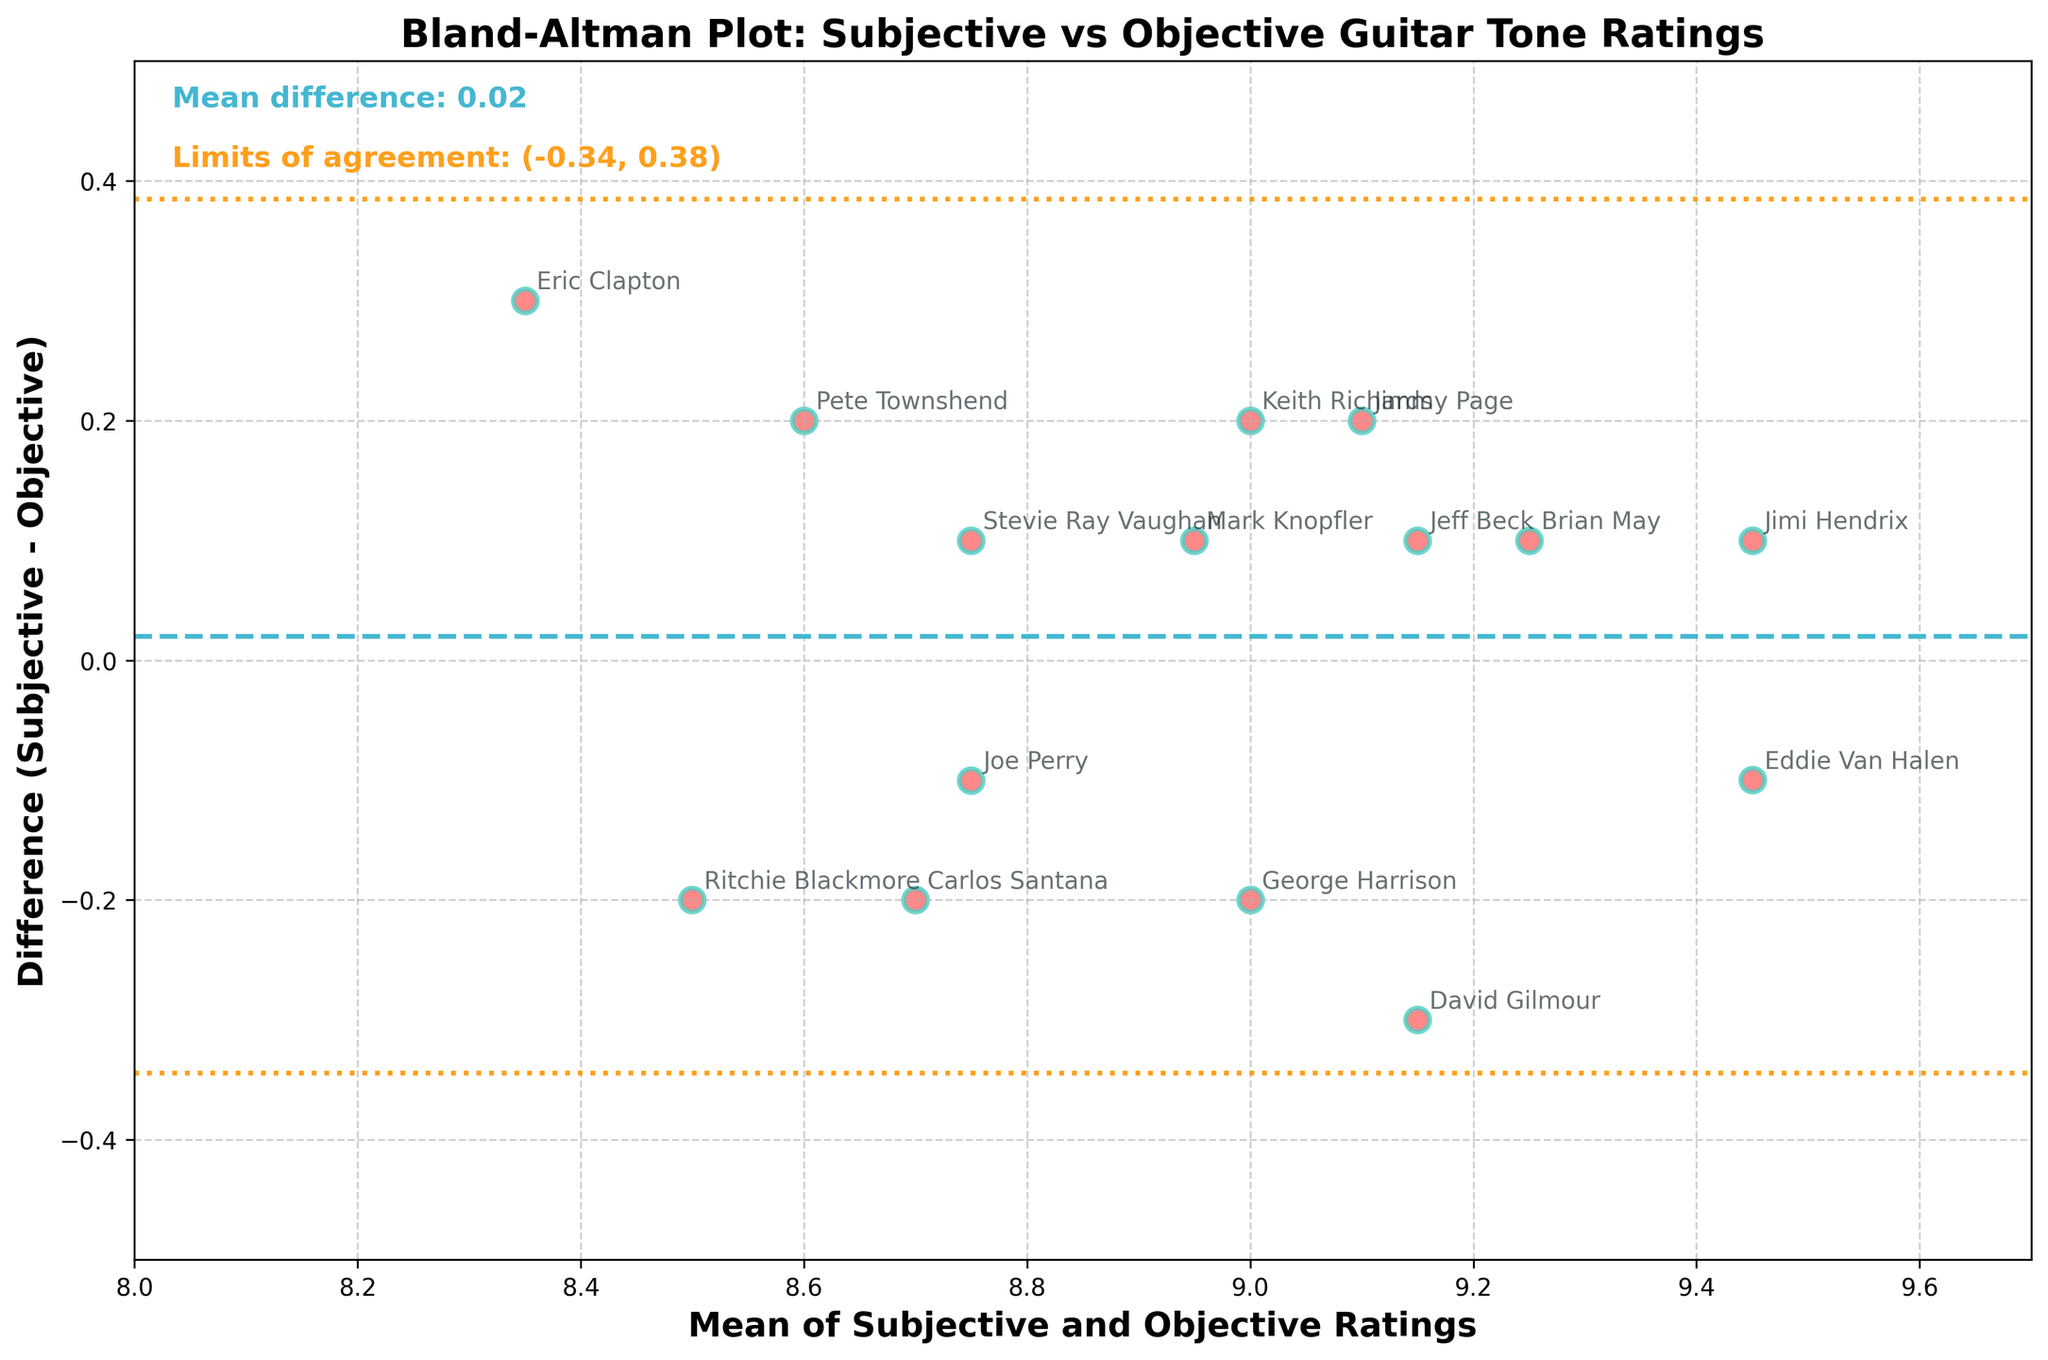What is the title of the figure? The title is usually displayed at the top of the figure and provides a summary of what the figure represents. By looking at the top of the figure, we can see the title "Bland-Altman Plot: Subjective vs Objective Guitar Tone Ratings".
Answer: Bland-Altman Plot: Subjective vs Objective Guitar Tone Ratings How many guitarists' tone ratings are plotted in the figure? By counting the number of individual data points or annotated names in the scatter plot, we can determine the total number of guitarists. Each guitarist has one corresponding data point.
Answer: 15 What do the horizontal dashed and dotted lines represent in this plot? The dashed line represents the mean difference between subjective and objective ratings, while the dotted lines represent the limits of agreement (mean difference ± 1.96 times the standard deviation). These lines help to understand the agreement between the two rating methods.
Answer: Mean difference and limits of agreement What is the mean difference between subjective and objective ratings? The mean difference is indicated by the value next to the dashed line. It's also annotated on the plot for clarity. By referring to the text on the figure, we see that the mean difference is 0.01.
Answer: 0.01 What are the limits of agreement for the subjective vs objective guitar tone ratings? The limits of agreement are calculated as the mean difference ± 1.96 times the standard deviation. These are shown by the two dotted lines and are also annotated on the plot. The figure indicates limits of agreement as (-0.27, 0.29).
Answer: (-0.27, 0.29) Which guitarist's tone rating has the largest positive difference between subjective and objective ratings? By observing the data points, we look for the largest positive difference (subjective rating higher than objective rating). From the plot, Jimi Hendrix's data point appears to have the highest positive difference.
Answer: Jimi Hendrix Which guitarist's tone rating has the largest negative difference between subjective and objective ratings? By looking for the data point lowest on the y-axis (subjective rating lower than objective rating), David Gilmour's data point indicates the largest negative difference.
Answer: David Gilmour Are there any data points that lie outside the limits of agreement? Data points outside the dotted lines representing the limits of agreement will indicate poor agreement for those ratings. By inspecting the plot, we see no data points outside these boundaries.
Answer: No What is the spread of the differences between subjective and objective ratings? To determine the spread, we look at the range of differences (from the highest positive difference to the lowest negative difference). From the plot, the differences range from approximately -0.3 to 0.3, giving a spread of 0.6.
Answer: 0.6 Do the majority of data points cluster around the mean difference line? The scatter of data points around the mean difference line (dashed line) indicates the level of agreement. By observing the distribution of points, we note that most points are close to the mean difference line, showing good overall agreement.
Answer: Yes 